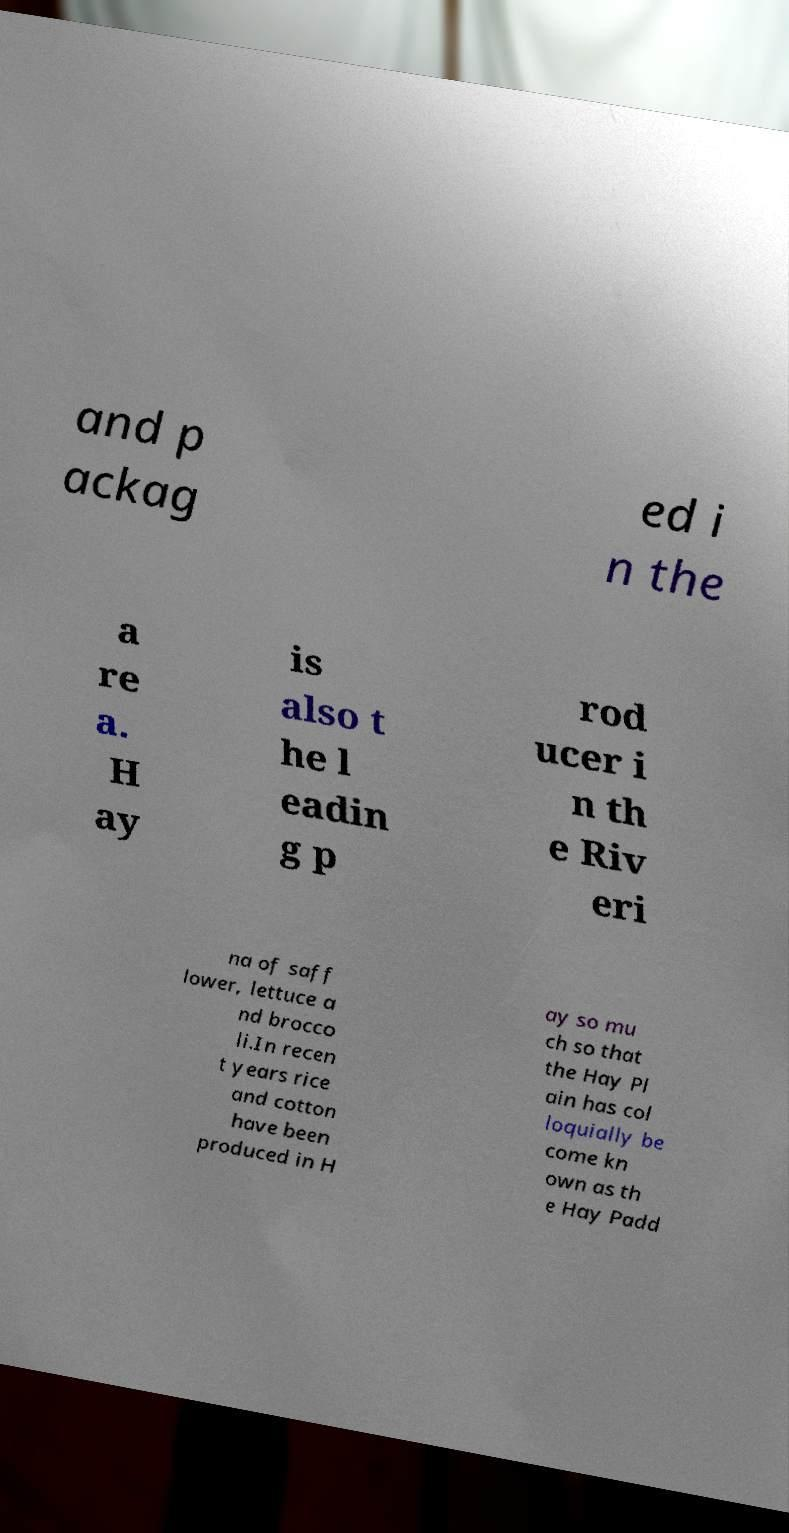Could you extract and type out the text from this image? and p ackag ed i n the a re a. H ay is also t he l eadin g p rod ucer i n th e Riv eri na of saff lower, lettuce a nd brocco li.In recen t years rice and cotton have been produced in H ay so mu ch so that the Hay Pl ain has col loquially be come kn own as th e Hay Padd 